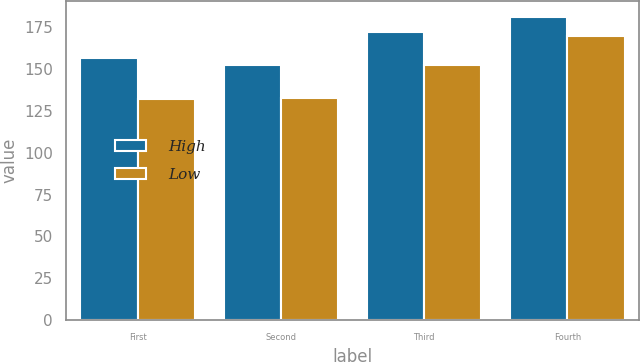<chart> <loc_0><loc_0><loc_500><loc_500><stacked_bar_chart><ecel><fcel>First<fcel>Second<fcel>Third<fcel>Fourth<nl><fcel>High<fcel>156.53<fcel>152.54<fcel>172.19<fcel>181.55<nl><fcel>Low<fcel>132.19<fcel>132.88<fcel>152.86<fcel>169.64<nl></chart> 